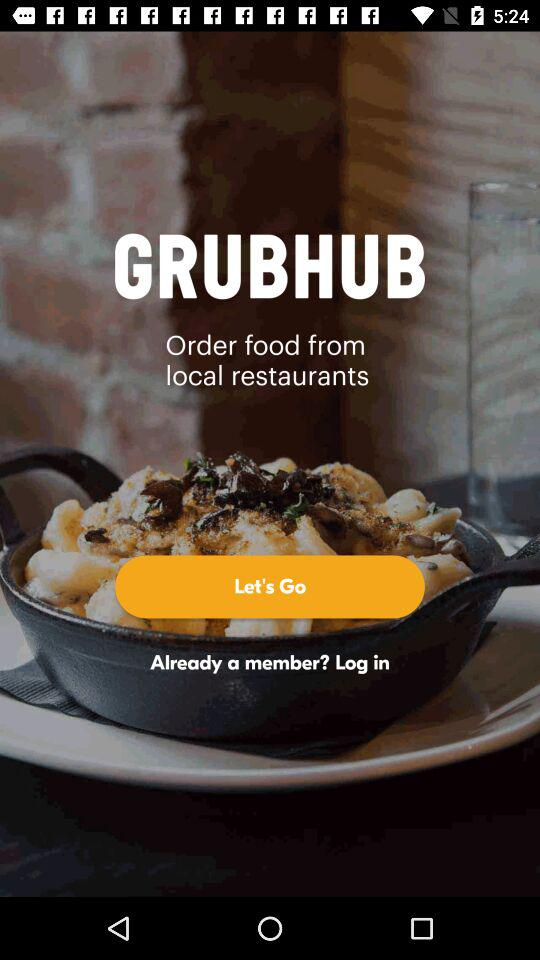What is the name of the application? The name of the application is "GRUBHUB". 